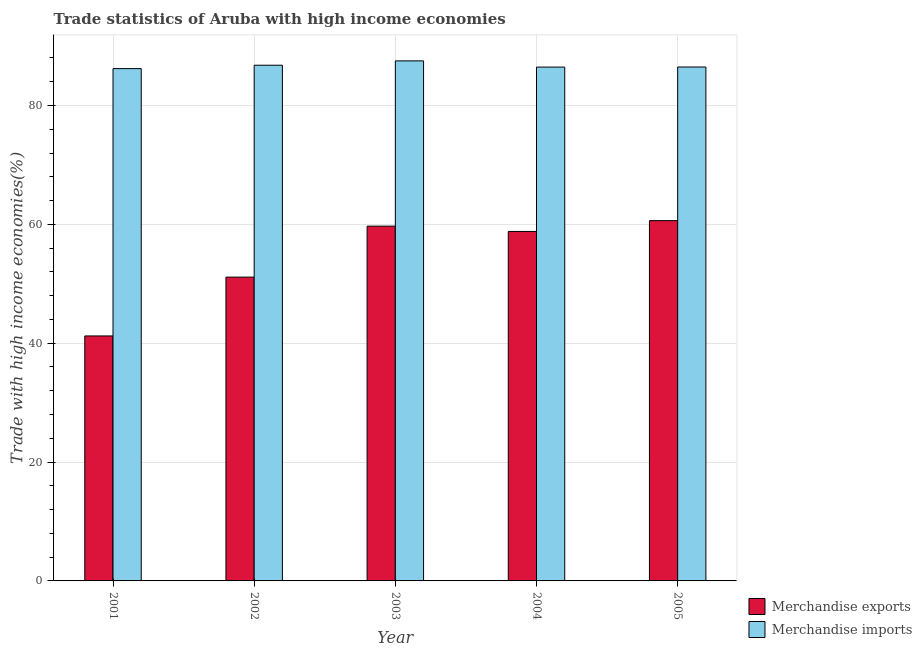How many different coloured bars are there?
Provide a succinct answer. 2. How many bars are there on the 4th tick from the left?
Your answer should be compact. 2. What is the label of the 5th group of bars from the left?
Provide a succinct answer. 2005. What is the merchandise exports in 2004?
Make the answer very short. 58.81. Across all years, what is the maximum merchandise imports?
Make the answer very short. 87.51. Across all years, what is the minimum merchandise exports?
Your answer should be compact. 41.23. What is the total merchandise imports in the graph?
Make the answer very short. 433.46. What is the difference between the merchandise imports in 2001 and that in 2005?
Your answer should be compact. -0.27. What is the difference between the merchandise exports in 2005 and the merchandise imports in 2001?
Your answer should be very brief. 19.41. What is the average merchandise imports per year?
Keep it short and to the point. 86.69. What is the ratio of the merchandise imports in 2001 to that in 2004?
Make the answer very short. 1. Is the merchandise exports in 2002 less than that in 2004?
Provide a succinct answer. Yes. What is the difference between the highest and the second highest merchandise exports?
Offer a very short reply. 0.93. What is the difference between the highest and the lowest merchandise imports?
Offer a very short reply. 1.3. In how many years, is the merchandise imports greater than the average merchandise imports taken over all years?
Your response must be concise. 2. Is the sum of the merchandise imports in 2001 and 2002 greater than the maximum merchandise exports across all years?
Offer a terse response. Yes. What does the 1st bar from the right in 2005 represents?
Your response must be concise. Merchandise imports. How many bars are there?
Ensure brevity in your answer.  10. Are all the bars in the graph horizontal?
Your answer should be very brief. No. What is the difference between two consecutive major ticks on the Y-axis?
Provide a succinct answer. 20. Are the values on the major ticks of Y-axis written in scientific E-notation?
Offer a very short reply. No. Does the graph contain any zero values?
Make the answer very short. No. Where does the legend appear in the graph?
Your answer should be very brief. Bottom right. How are the legend labels stacked?
Your answer should be compact. Vertical. What is the title of the graph?
Give a very brief answer. Trade statistics of Aruba with high income economies. What is the label or title of the Y-axis?
Your answer should be compact. Trade with high income economies(%). What is the Trade with high income economies(%) in Merchandise exports in 2001?
Offer a terse response. 41.23. What is the Trade with high income economies(%) of Merchandise imports in 2001?
Your response must be concise. 86.21. What is the Trade with high income economies(%) in Merchandise exports in 2002?
Give a very brief answer. 51.13. What is the Trade with high income economies(%) in Merchandise imports in 2002?
Provide a succinct answer. 86.78. What is the Trade with high income economies(%) of Merchandise exports in 2003?
Keep it short and to the point. 59.7. What is the Trade with high income economies(%) of Merchandise imports in 2003?
Provide a succinct answer. 87.51. What is the Trade with high income economies(%) of Merchandise exports in 2004?
Your response must be concise. 58.81. What is the Trade with high income economies(%) of Merchandise imports in 2004?
Provide a short and direct response. 86.47. What is the Trade with high income economies(%) of Merchandise exports in 2005?
Make the answer very short. 60.63. What is the Trade with high income economies(%) of Merchandise imports in 2005?
Offer a terse response. 86.48. Across all years, what is the maximum Trade with high income economies(%) of Merchandise exports?
Provide a short and direct response. 60.63. Across all years, what is the maximum Trade with high income economies(%) in Merchandise imports?
Your answer should be compact. 87.51. Across all years, what is the minimum Trade with high income economies(%) of Merchandise exports?
Your response must be concise. 41.23. Across all years, what is the minimum Trade with high income economies(%) in Merchandise imports?
Provide a short and direct response. 86.21. What is the total Trade with high income economies(%) of Merchandise exports in the graph?
Your response must be concise. 271.49. What is the total Trade with high income economies(%) of Merchandise imports in the graph?
Offer a terse response. 433.46. What is the difference between the Trade with high income economies(%) of Merchandise imports in 2001 and that in 2002?
Your response must be concise. -0.57. What is the difference between the Trade with high income economies(%) of Merchandise exports in 2001 and that in 2003?
Provide a short and direct response. -18.48. What is the difference between the Trade with high income economies(%) in Merchandise imports in 2001 and that in 2003?
Provide a short and direct response. -1.3. What is the difference between the Trade with high income economies(%) of Merchandise exports in 2001 and that in 2004?
Ensure brevity in your answer.  -17.59. What is the difference between the Trade with high income economies(%) of Merchandise imports in 2001 and that in 2004?
Offer a terse response. -0.26. What is the difference between the Trade with high income economies(%) of Merchandise exports in 2001 and that in 2005?
Provide a short and direct response. -19.41. What is the difference between the Trade with high income economies(%) of Merchandise imports in 2001 and that in 2005?
Your response must be concise. -0.27. What is the difference between the Trade with high income economies(%) in Merchandise exports in 2002 and that in 2003?
Provide a succinct answer. -8.58. What is the difference between the Trade with high income economies(%) in Merchandise imports in 2002 and that in 2003?
Your response must be concise. -0.73. What is the difference between the Trade with high income economies(%) of Merchandise exports in 2002 and that in 2004?
Keep it short and to the point. -7.69. What is the difference between the Trade with high income economies(%) of Merchandise imports in 2002 and that in 2004?
Make the answer very short. 0.31. What is the difference between the Trade with high income economies(%) in Merchandise exports in 2002 and that in 2005?
Keep it short and to the point. -9.51. What is the difference between the Trade with high income economies(%) in Merchandise imports in 2002 and that in 2005?
Provide a short and direct response. 0.3. What is the difference between the Trade with high income economies(%) in Merchandise exports in 2003 and that in 2004?
Offer a terse response. 0.89. What is the difference between the Trade with high income economies(%) of Merchandise imports in 2003 and that in 2004?
Make the answer very short. 1.05. What is the difference between the Trade with high income economies(%) of Merchandise exports in 2003 and that in 2005?
Your response must be concise. -0.93. What is the difference between the Trade with high income economies(%) in Merchandise imports in 2003 and that in 2005?
Ensure brevity in your answer.  1.03. What is the difference between the Trade with high income economies(%) in Merchandise exports in 2004 and that in 2005?
Provide a short and direct response. -1.82. What is the difference between the Trade with high income economies(%) in Merchandise imports in 2004 and that in 2005?
Give a very brief answer. -0.01. What is the difference between the Trade with high income economies(%) in Merchandise exports in 2001 and the Trade with high income economies(%) in Merchandise imports in 2002?
Offer a very short reply. -45.56. What is the difference between the Trade with high income economies(%) in Merchandise exports in 2001 and the Trade with high income economies(%) in Merchandise imports in 2003?
Your response must be concise. -46.29. What is the difference between the Trade with high income economies(%) of Merchandise exports in 2001 and the Trade with high income economies(%) of Merchandise imports in 2004?
Your response must be concise. -45.24. What is the difference between the Trade with high income economies(%) in Merchandise exports in 2001 and the Trade with high income economies(%) in Merchandise imports in 2005?
Your answer should be compact. -45.26. What is the difference between the Trade with high income economies(%) of Merchandise exports in 2002 and the Trade with high income economies(%) of Merchandise imports in 2003?
Provide a short and direct response. -36.39. What is the difference between the Trade with high income economies(%) of Merchandise exports in 2002 and the Trade with high income economies(%) of Merchandise imports in 2004?
Your response must be concise. -35.34. What is the difference between the Trade with high income economies(%) of Merchandise exports in 2002 and the Trade with high income economies(%) of Merchandise imports in 2005?
Your answer should be compact. -35.36. What is the difference between the Trade with high income economies(%) in Merchandise exports in 2003 and the Trade with high income economies(%) in Merchandise imports in 2004?
Your answer should be compact. -26.77. What is the difference between the Trade with high income economies(%) of Merchandise exports in 2003 and the Trade with high income economies(%) of Merchandise imports in 2005?
Give a very brief answer. -26.78. What is the difference between the Trade with high income economies(%) of Merchandise exports in 2004 and the Trade with high income economies(%) of Merchandise imports in 2005?
Your response must be concise. -27.67. What is the average Trade with high income economies(%) in Merchandise exports per year?
Your answer should be compact. 54.3. What is the average Trade with high income economies(%) of Merchandise imports per year?
Your answer should be compact. 86.69. In the year 2001, what is the difference between the Trade with high income economies(%) in Merchandise exports and Trade with high income economies(%) in Merchandise imports?
Your answer should be very brief. -44.99. In the year 2002, what is the difference between the Trade with high income economies(%) in Merchandise exports and Trade with high income economies(%) in Merchandise imports?
Your response must be concise. -35.66. In the year 2003, what is the difference between the Trade with high income economies(%) of Merchandise exports and Trade with high income economies(%) of Merchandise imports?
Provide a short and direct response. -27.81. In the year 2004, what is the difference between the Trade with high income economies(%) of Merchandise exports and Trade with high income economies(%) of Merchandise imports?
Ensure brevity in your answer.  -27.66. In the year 2005, what is the difference between the Trade with high income economies(%) of Merchandise exports and Trade with high income economies(%) of Merchandise imports?
Offer a terse response. -25.85. What is the ratio of the Trade with high income economies(%) of Merchandise exports in 2001 to that in 2002?
Make the answer very short. 0.81. What is the ratio of the Trade with high income economies(%) in Merchandise imports in 2001 to that in 2002?
Make the answer very short. 0.99. What is the ratio of the Trade with high income economies(%) of Merchandise exports in 2001 to that in 2003?
Give a very brief answer. 0.69. What is the ratio of the Trade with high income economies(%) of Merchandise imports in 2001 to that in 2003?
Your answer should be very brief. 0.99. What is the ratio of the Trade with high income economies(%) in Merchandise exports in 2001 to that in 2004?
Give a very brief answer. 0.7. What is the ratio of the Trade with high income economies(%) in Merchandise exports in 2001 to that in 2005?
Your response must be concise. 0.68. What is the ratio of the Trade with high income economies(%) of Merchandise imports in 2001 to that in 2005?
Offer a terse response. 1. What is the ratio of the Trade with high income economies(%) in Merchandise exports in 2002 to that in 2003?
Offer a terse response. 0.86. What is the ratio of the Trade with high income economies(%) of Merchandise exports in 2002 to that in 2004?
Keep it short and to the point. 0.87. What is the ratio of the Trade with high income economies(%) of Merchandise exports in 2002 to that in 2005?
Provide a short and direct response. 0.84. What is the ratio of the Trade with high income economies(%) in Merchandise exports in 2003 to that in 2004?
Give a very brief answer. 1.02. What is the ratio of the Trade with high income economies(%) of Merchandise imports in 2003 to that in 2004?
Offer a very short reply. 1.01. What is the ratio of the Trade with high income economies(%) in Merchandise exports in 2003 to that in 2005?
Your answer should be compact. 0.98. What is the ratio of the Trade with high income economies(%) in Merchandise imports in 2003 to that in 2005?
Your answer should be very brief. 1.01. What is the ratio of the Trade with high income economies(%) of Merchandise exports in 2004 to that in 2005?
Offer a terse response. 0.97. What is the difference between the highest and the second highest Trade with high income economies(%) in Merchandise exports?
Offer a very short reply. 0.93. What is the difference between the highest and the second highest Trade with high income economies(%) in Merchandise imports?
Your response must be concise. 0.73. What is the difference between the highest and the lowest Trade with high income economies(%) of Merchandise exports?
Ensure brevity in your answer.  19.41. What is the difference between the highest and the lowest Trade with high income economies(%) in Merchandise imports?
Ensure brevity in your answer.  1.3. 